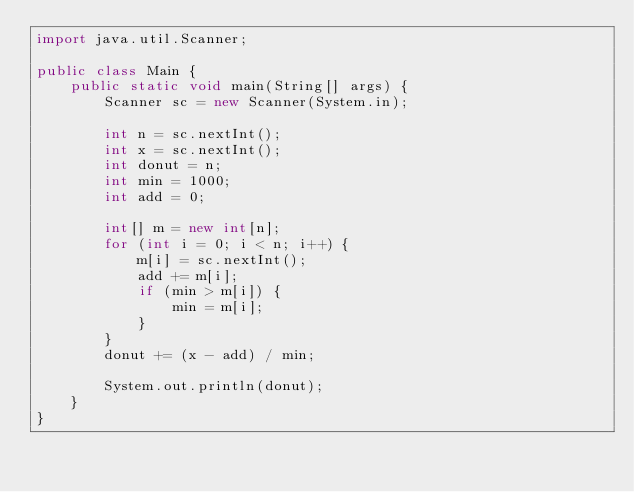Convert code to text. <code><loc_0><loc_0><loc_500><loc_500><_Java_>import java.util.Scanner;

public class Main {
    public static void main(String[] args) {
        Scanner sc = new Scanner(System.in);

        int n = sc.nextInt();
        int x = sc.nextInt();
        int donut = n;
        int min = 1000;
        int add = 0;

        int[] m = new int[n];
        for (int i = 0; i < n; i++) {
            m[i] = sc.nextInt();
            add += m[i];
            if (min > m[i]) {
                min = m[i];
            }
        }
        donut += (x - add) / min;

        System.out.println(donut);
    }
}</code> 